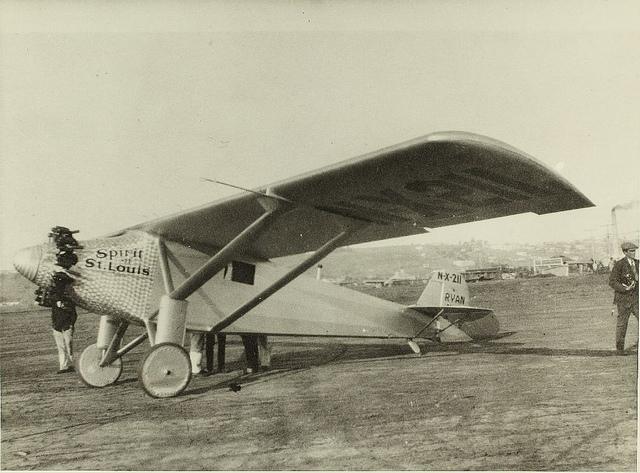What is this?
Write a very short answer. Plane. How many engines are in the plane?
Answer briefly. 1. Black and white?
Give a very brief answer. Yes. What is the plane doing on the beach?
Quick response, please. Sitting. What color is the photo?
Write a very short answer. Black and white. How many people are shown here?
Concise answer only. 2. Is this a single wing plane?
Quick response, please. Yes. What number is on the plane?
Write a very short answer. 211. How will the passengers board the plane?
Answer briefly. Door. 